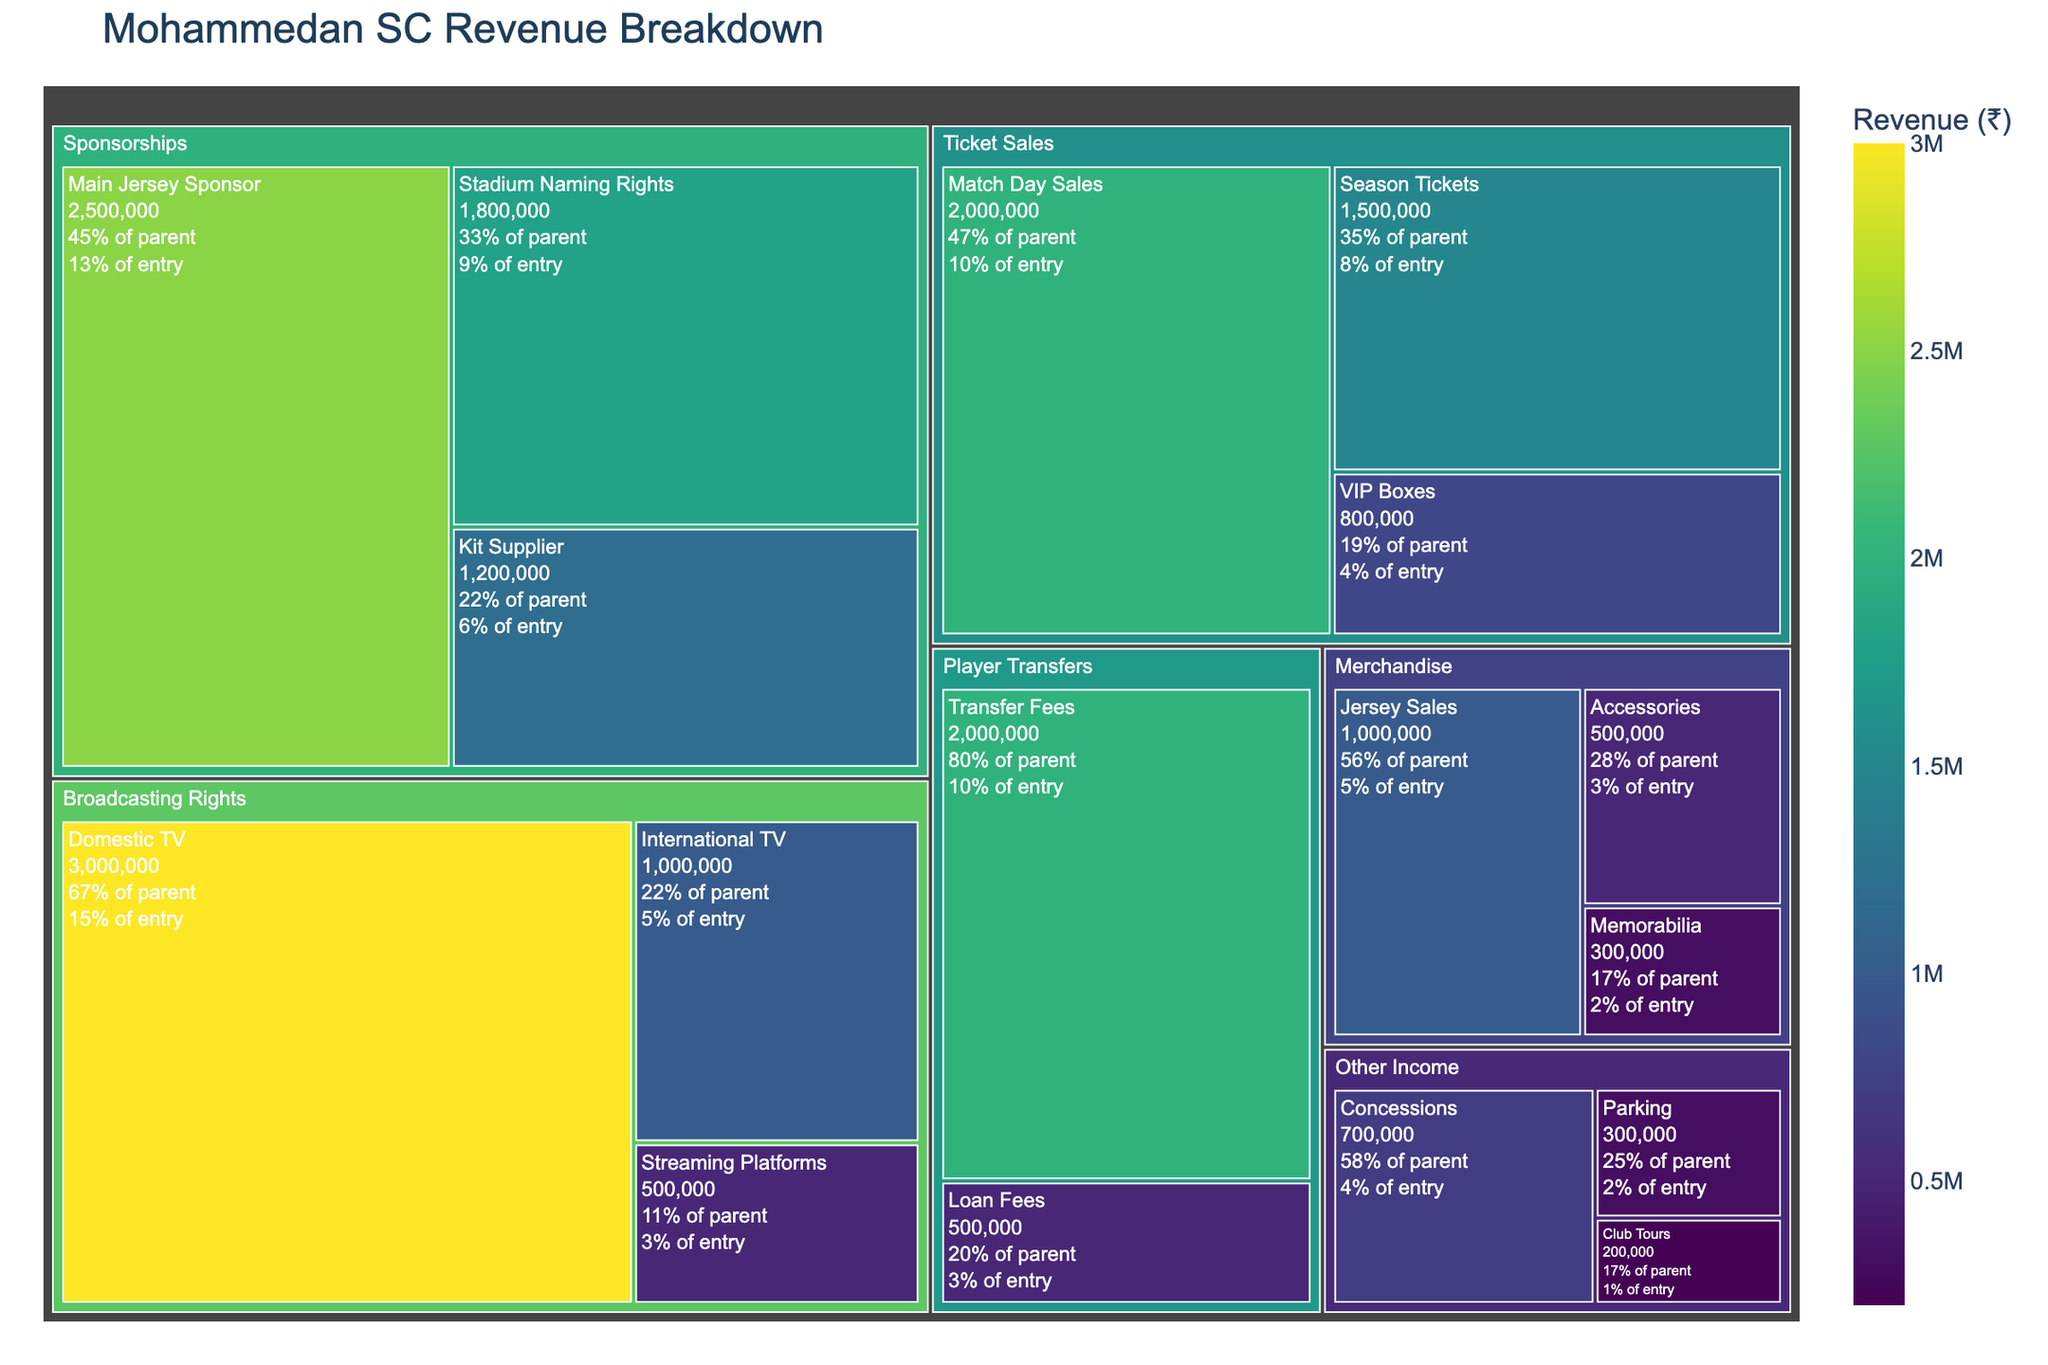What is the largest revenue source for Mohammedan SC? To determine the largest revenue source, look for the largest segment in the treemap, which represents the biggest portion of revenue. Broadcasting Rights (Domestic TV) appears to have the largest block.
Answer: Broadcasting Rights (Domestic TV) How much revenue does the Main Jersey Sponsor bring in? The Main Jersey Sponsor is a subcategory under Sponsorships. Locate this subcategory in the treemap and refer to the revenue value displayed.
Answer: ₹2,500,000 Which category generates more revenue: Ticket Sales or Sponsorships? Sum the revenue from the subcategories under Ticket Sales and compare it to the sum of the revenue from Sponsorships. Ticket Sales: ₹1,500,000 (Season Tickets) + ₹2,000,000 (Match Day Sales) + ₹800,000 (VIP Boxes) = ₹4,300,000. Sponsorships: ₹2,500,000 (Main Jersey Sponsor) + ₹1,800,000 (Stadium Naming Rights) + ₹1,200,000 (Kit Supplier) = ₹5,500,000. Sponsorships generate more revenue.
Answer: Sponsorships What percentage of the total revenue comes from Player Transfers? First, sum the total revenue from all categories, then sum the revenue within Player Transfers, and finally, calculate the percentage. Total revenue is ₹17,800,000. Player Transfers: ₹2,000,000 + ₹500,000 = ₹2,500,000. Percentage: (₹2,500,000 / ₹17,800,000) * 100 ≈ 14.0%
Answer: 14.0% How does the revenue from Domestic TV compare to International TV? Compare the two subcategories under Broadcasting Rights. The revenue from Domestic TV is ₹3,000,000, and from International TV is ₹1,000,000. Domestic TV generates 3 times more revenue.
Answer: Domestic TV generates 3 times more revenue Which has a higher revenue: VIP Boxes or Streaming Platforms? Look for VIP Boxes under Ticket Sales and Streaming Platforms under Broadcasting Rights. VIP Boxes generate ₹800,000, while Streaming Platforms generate ₹500,000.
Answer: VIP Boxes How much total revenue comes from Merchandise? Sum the values of the subcategories under Merchandise: ₹1,000,000 (Jersey Sales) + ₹500,000 (Accessories) + ₹300,000 (Memorabilia) = ₹1,800,000.
Answer: ₹1,800,000 What is the smallest revenue source within Other Income? Look at the subcategories under Other Income and identify the one with the smallest value. Club Tours has the smallest value of ₹200,000.
Answer: Club Tours Which category has the lowest contribution to the total revenue? Compare the total revenue of each main category: Sponsorships (₹5,500,000), Ticket Sales (₹4,300,000), Merchandise (₹1,800,000), Broadcasting Rights (₹4,500,000), Player Transfers (₹2,500,000), Other Income (₹1,200,000). Other Income has the lowest contribution.
Answer: Other Income 